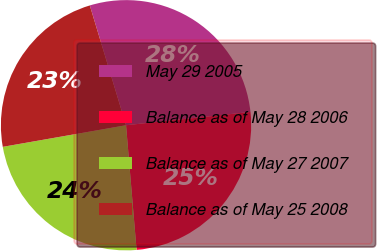Convert chart. <chart><loc_0><loc_0><loc_500><loc_500><pie_chart><fcel>May 29 2005<fcel>Balance as of May 28 2006<fcel>Balance as of May 27 2007<fcel>Balance as of May 25 2008<nl><fcel>27.98%<fcel>25.35%<fcel>23.58%<fcel>23.09%<nl></chart> 